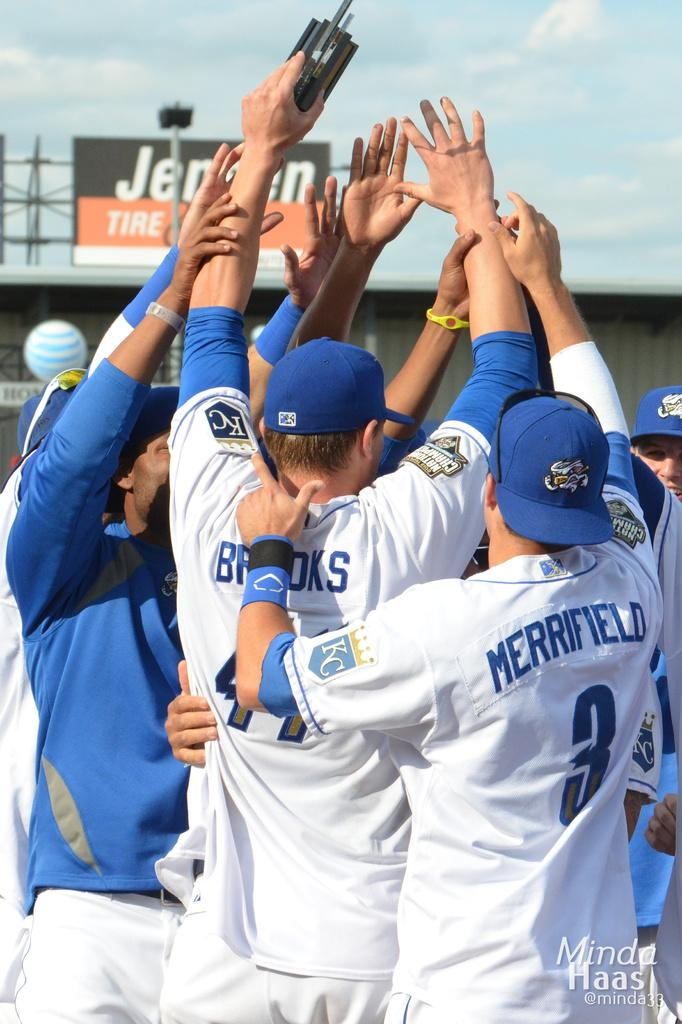<image>
Offer a succinct explanation of the picture presented. A baseball team huddled up including Merrifield and Brooks. 